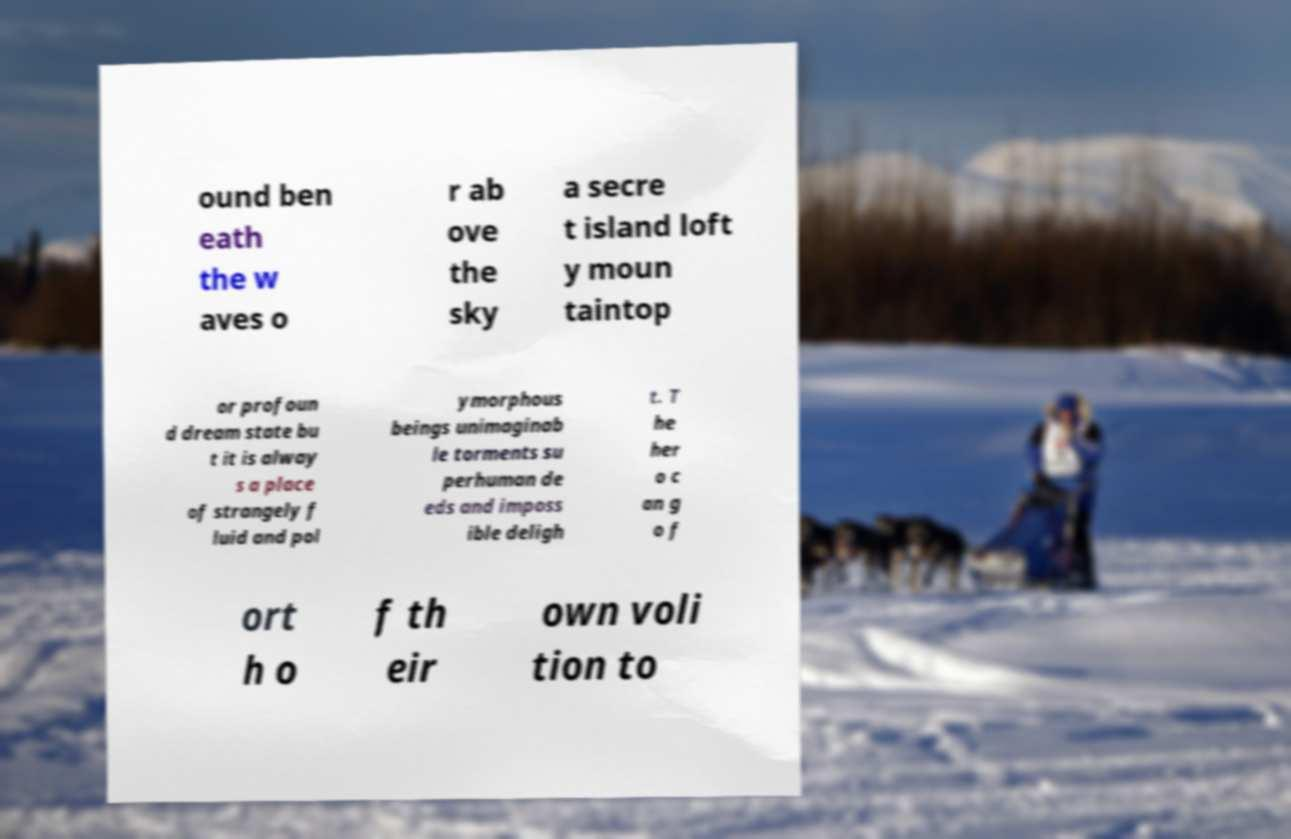There's text embedded in this image that I need extracted. Can you transcribe it verbatim? ound ben eath the w aves o r ab ove the sky a secre t island loft y moun taintop or profoun d dream state bu t it is alway s a place of strangely f luid and pol ymorphous beings unimaginab le torments su perhuman de eds and imposs ible deligh t. T he her o c an g o f ort h o f th eir own voli tion to 